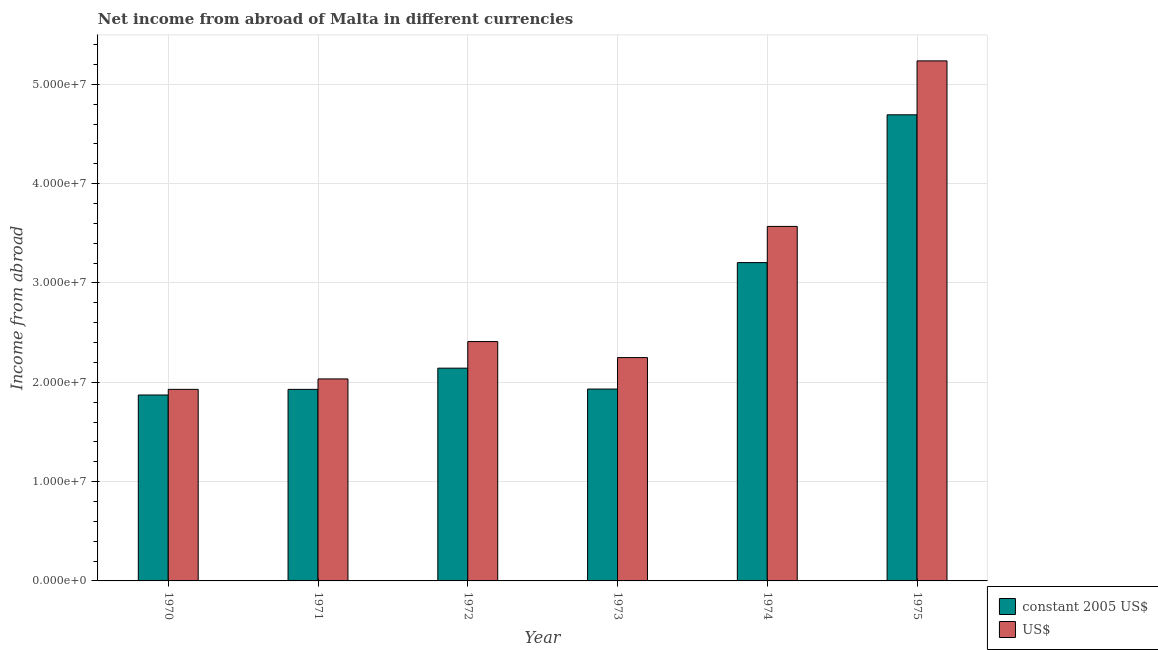How many different coloured bars are there?
Your answer should be compact. 2. Are the number of bars per tick equal to the number of legend labels?
Make the answer very short. Yes. What is the income from abroad in us$ in 1973?
Offer a terse response. 2.25e+07. Across all years, what is the maximum income from abroad in us$?
Your answer should be compact. 5.24e+07. Across all years, what is the minimum income from abroad in constant 2005 us$?
Your answer should be compact. 1.87e+07. In which year was the income from abroad in us$ maximum?
Your response must be concise. 1975. In which year was the income from abroad in us$ minimum?
Offer a terse response. 1970. What is the total income from abroad in us$ in the graph?
Keep it short and to the point. 1.74e+08. What is the difference between the income from abroad in constant 2005 us$ in 1970 and that in 1974?
Your answer should be very brief. -1.33e+07. What is the difference between the income from abroad in constant 2005 us$ in 1971 and the income from abroad in us$ in 1972?
Offer a very short reply. -2.13e+06. What is the average income from abroad in us$ per year?
Offer a very short reply. 2.90e+07. What is the ratio of the income from abroad in us$ in 1972 to that in 1975?
Ensure brevity in your answer.  0.46. What is the difference between the highest and the second highest income from abroad in us$?
Offer a terse response. 1.67e+07. What is the difference between the highest and the lowest income from abroad in us$?
Give a very brief answer. 3.31e+07. What does the 2nd bar from the left in 1973 represents?
Your answer should be compact. US$. What does the 2nd bar from the right in 1972 represents?
Offer a terse response. Constant 2005 us$. How many years are there in the graph?
Make the answer very short. 6. What is the difference between two consecutive major ticks on the Y-axis?
Your answer should be very brief. 1.00e+07. Are the values on the major ticks of Y-axis written in scientific E-notation?
Give a very brief answer. Yes. How many legend labels are there?
Provide a short and direct response. 2. What is the title of the graph?
Offer a very short reply. Net income from abroad of Malta in different currencies. Does "Imports" appear as one of the legend labels in the graph?
Offer a terse response. No. What is the label or title of the Y-axis?
Offer a terse response. Income from abroad. What is the Income from abroad in constant 2005 US$ in 1970?
Provide a short and direct response. 1.87e+07. What is the Income from abroad of US$ in 1970?
Your answer should be compact. 1.93e+07. What is the Income from abroad of constant 2005 US$ in 1971?
Keep it short and to the point. 1.93e+07. What is the Income from abroad in US$ in 1971?
Keep it short and to the point. 2.03e+07. What is the Income from abroad of constant 2005 US$ in 1972?
Provide a short and direct response. 2.14e+07. What is the Income from abroad of US$ in 1972?
Make the answer very short. 2.41e+07. What is the Income from abroad in constant 2005 US$ in 1973?
Your answer should be very brief. 1.93e+07. What is the Income from abroad in US$ in 1973?
Your answer should be very brief. 2.25e+07. What is the Income from abroad in constant 2005 US$ in 1974?
Your response must be concise. 3.21e+07. What is the Income from abroad in US$ in 1974?
Ensure brevity in your answer.  3.57e+07. What is the Income from abroad in constant 2005 US$ in 1975?
Make the answer very short. 4.69e+07. What is the Income from abroad in US$ in 1975?
Offer a very short reply. 5.24e+07. Across all years, what is the maximum Income from abroad in constant 2005 US$?
Ensure brevity in your answer.  4.69e+07. Across all years, what is the maximum Income from abroad of US$?
Your response must be concise. 5.24e+07. Across all years, what is the minimum Income from abroad in constant 2005 US$?
Your answer should be very brief. 1.87e+07. Across all years, what is the minimum Income from abroad of US$?
Offer a very short reply. 1.93e+07. What is the total Income from abroad in constant 2005 US$ in the graph?
Provide a short and direct response. 1.58e+08. What is the total Income from abroad of US$ in the graph?
Provide a succinct answer. 1.74e+08. What is the difference between the Income from abroad in constant 2005 US$ in 1970 and that in 1971?
Make the answer very short. -5.66e+05. What is the difference between the Income from abroad in US$ in 1970 and that in 1971?
Provide a short and direct response. -1.05e+06. What is the difference between the Income from abroad in constant 2005 US$ in 1970 and that in 1972?
Your response must be concise. -2.70e+06. What is the difference between the Income from abroad in US$ in 1970 and that in 1972?
Offer a terse response. -4.81e+06. What is the difference between the Income from abroad of constant 2005 US$ in 1970 and that in 1973?
Offer a very short reply. -5.97e+05. What is the difference between the Income from abroad of US$ in 1970 and that in 1973?
Offer a very short reply. -3.20e+06. What is the difference between the Income from abroad in constant 2005 US$ in 1970 and that in 1974?
Keep it short and to the point. -1.33e+07. What is the difference between the Income from abroad of US$ in 1970 and that in 1974?
Your answer should be compact. -1.64e+07. What is the difference between the Income from abroad of constant 2005 US$ in 1970 and that in 1975?
Keep it short and to the point. -2.82e+07. What is the difference between the Income from abroad of US$ in 1970 and that in 1975?
Your answer should be very brief. -3.31e+07. What is the difference between the Income from abroad of constant 2005 US$ in 1971 and that in 1972?
Your response must be concise. -2.13e+06. What is the difference between the Income from abroad of US$ in 1971 and that in 1972?
Offer a very short reply. -3.76e+06. What is the difference between the Income from abroad of constant 2005 US$ in 1971 and that in 1973?
Keep it short and to the point. -3.07e+04. What is the difference between the Income from abroad in US$ in 1971 and that in 1973?
Your answer should be compact. -2.15e+06. What is the difference between the Income from abroad of constant 2005 US$ in 1971 and that in 1974?
Provide a short and direct response. -1.28e+07. What is the difference between the Income from abroad in US$ in 1971 and that in 1974?
Your response must be concise. -1.54e+07. What is the difference between the Income from abroad in constant 2005 US$ in 1971 and that in 1975?
Provide a short and direct response. -2.76e+07. What is the difference between the Income from abroad of US$ in 1971 and that in 1975?
Your response must be concise. -3.20e+07. What is the difference between the Income from abroad in constant 2005 US$ in 1972 and that in 1973?
Your answer should be very brief. 2.10e+06. What is the difference between the Income from abroad in US$ in 1972 and that in 1973?
Make the answer very short. 1.61e+06. What is the difference between the Income from abroad of constant 2005 US$ in 1972 and that in 1974?
Your response must be concise. -1.06e+07. What is the difference between the Income from abroad of US$ in 1972 and that in 1974?
Your response must be concise. -1.16e+07. What is the difference between the Income from abroad in constant 2005 US$ in 1972 and that in 1975?
Provide a succinct answer. -2.55e+07. What is the difference between the Income from abroad of US$ in 1972 and that in 1975?
Provide a succinct answer. -2.83e+07. What is the difference between the Income from abroad of constant 2005 US$ in 1973 and that in 1974?
Ensure brevity in your answer.  -1.27e+07. What is the difference between the Income from abroad of US$ in 1973 and that in 1974?
Offer a very short reply. -1.32e+07. What is the difference between the Income from abroad of constant 2005 US$ in 1973 and that in 1975?
Your response must be concise. -2.76e+07. What is the difference between the Income from abroad in US$ in 1973 and that in 1975?
Offer a terse response. -2.99e+07. What is the difference between the Income from abroad in constant 2005 US$ in 1974 and that in 1975?
Make the answer very short. -1.49e+07. What is the difference between the Income from abroad of US$ in 1974 and that in 1975?
Make the answer very short. -1.67e+07. What is the difference between the Income from abroad of constant 2005 US$ in 1970 and the Income from abroad of US$ in 1971?
Offer a very short reply. -1.62e+06. What is the difference between the Income from abroad in constant 2005 US$ in 1970 and the Income from abroad in US$ in 1972?
Make the answer very short. -5.38e+06. What is the difference between the Income from abroad of constant 2005 US$ in 1970 and the Income from abroad of US$ in 1973?
Provide a short and direct response. -3.77e+06. What is the difference between the Income from abroad of constant 2005 US$ in 1970 and the Income from abroad of US$ in 1974?
Your answer should be compact. -1.70e+07. What is the difference between the Income from abroad in constant 2005 US$ in 1970 and the Income from abroad in US$ in 1975?
Provide a short and direct response. -3.36e+07. What is the difference between the Income from abroad of constant 2005 US$ in 1971 and the Income from abroad of US$ in 1972?
Your response must be concise. -4.81e+06. What is the difference between the Income from abroad of constant 2005 US$ in 1971 and the Income from abroad of US$ in 1973?
Give a very brief answer. -3.20e+06. What is the difference between the Income from abroad in constant 2005 US$ in 1971 and the Income from abroad in US$ in 1974?
Your answer should be compact. -1.64e+07. What is the difference between the Income from abroad of constant 2005 US$ in 1971 and the Income from abroad of US$ in 1975?
Keep it short and to the point. -3.31e+07. What is the difference between the Income from abroad of constant 2005 US$ in 1972 and the Income from abroad of US$ in 1973?
Provide a short and direct response. -1.07e+06. What is the difference between the Income from abroad in constant 2005 US$ in 1972 and the Income from abroad in US$ in 1974?
Your answer should be compact. -1.43e+07. What is the difference between the Income from abroad in constant 2005 US$ in 1972 and the Income from abroad in US$ in 1975?
Ensure brevity in your answer.  -3.09e+07. What is the difference between the Income from abroad in constant 2005 US$ in 1973 and the Income from abroad in US$ in 1974?
Your answer should be very brief. -1.64e+07. What is the difference between the Income from abroad of constant 2005 US$ in 1973 and the Income from abroad of US$ in 1975?
Keep it short and to the point. -3.30e+07. What is the difference between the Income from abroad of constant 2005 US$ in 1974 and the Income from abroad of US$ in 1975?
Provide a short and direct response. -2.03e+07. What is the average Income from abroad of constant 2005 US$ per year?
Ensure brevity in your answer.  2.63e+07. What is the average Income from abroad in US$ per year?
Provide a short and direct response. 2.90e+07. In the year 1970, what is the difference between the Income from abroad of constant 2005 US$ and Income from abroad of US$?
Offer a very short reply. -5.68e+05. In the year 1971, what is the difference between the Income from abroad in constant 2005 US$ and Income from abroad in US$?
Your answer should be very brief. -1.05e+06. In the year 1972, what is the difference between the Income from abroad in constant 2005 US$ and Income from abroad in US$?
Offer a very short reply. -2.68e+06. In the year 1973, what is the difference between the Income from abroad in constant 2005 US$ and Income from abroad in US$?
Ensure brevity in your answer.  -3.17e+06. In the year 1974, what is the difference between the Income from abroad of constant 2005 US$ and Income from abroad of US$?
Ensure brevity in your answer.  -3.64e+06. In the year 1975, what is the difference between the Income from abroad in constant 2005 US$ and Income from abroad in US$?
Make the answer very short. -5.43e+06. What is the ratio of the Income from abroad of constant 2005 US$ in 1970 to that in 1971?
Provide a succinct answer. 0.97. What is the ratio of the Income from abroad in US$ in 1970 to that in 1971?
Make the answer very short. 0.95. What is the ratio of the Income from abroad of constant 2005 US$ in 1970 to that in 1972?
Your answer should be compact. 0.87. What is the ratio of the Income from abroad of US$ in 1970 to that in 1972?
Provide a short and direct response. 0.8. What is the ratio of the Income from abroad of constant 2005 US$ in 1970 to that in 1973?
Your response must be concise. 0.97. What is the ratio of the Income from abroad in US$ in 1970 to that in 1973?
Make the answer very short. 0.86. What is the ratio of the Income from abroad in constant 2005 US$ in 1970 to that in 1974?
Provide a succinct answer. 0.58. What is the ratio of the Income from abroad in US$ in 1970 to that in 1974?
Offer a very short reply. 0.54. What is the ratio of the Income from abroad of constant 2005 US$ in 1970 to that in 1975?
Keep it short and to the point. 0.4. What is the ratio of the Income from abroad of US$ in 1970 to that in 1975?
Your answer should be compact. 0.37. What is the ratio of the Income from abroad of constant 2005 US$ in 1971 to that in 1972?
Your answer should be very brief. 0.9. What is the ratio of the Income from abroad of US$ in 1971 to that in 1972?
Offer a very short reply. 0.84. What is the ratio of the Income from abroad in constant 2005 US$ in 1971 to that in 1973?
Your response must be concise. 1. What is the ratio of the Income from abroad in US$ in 1971 to that in 1973?
Make the answer very short. 0.9. What is the ratio of the Income from abroad in constant 2005 US$ in 1971 to that in 1974?
Provide a short and direct response. 0.6. What is the ratio of the Income from abroad of US$ in 1971 to that in 1974?
Your response must be concise. 0.57. What is the ratio of the Income from abroad in constant 2005 US$ in 1971 to that in 1975?
Provide a succinct answer. 0.41. What is the ratio of the Income from abroad of US$ in 1971 to that in 1975?
Your answer should be compact. 0.39. What is the ratio of the Income from abroad in constant 2005 US$ in 1972 to that in 1973?
Make the answer very short. 1.11. What is the ratio of the Income from abroad in US$ in 1972 to that in 1973?
Your answer should be very brief. 1.07. What is the ratio of the Income from abroad of constant 2005 US$ in 1972 to that in 1974?
Your response must be concise. 0.67. What is the ratio of the Income from abroad of US$ in 1972 to that in 1974?
Your answer should be very brief. 0.68. What is the ratio of the Income from abroad of constant 2005 US$ in 1972 to that in 1975?
Keep it short and to the point. 0.46. What is the ratio of the Income from abroad in US$ in 1972 to that in 1975?
Provide a short and direct response. 0.46. What is the ratio of the Income from abroad of constant 2005 US$ in 1973 to that in 1974?
Provide a short and direct response. 0.6. What is the ratio of the Income from abroad in US$ in 1973 to that in 1974?
Offer a terse response. 0.63. What is the ratio of the Income from abroad of constant 2005 US$ in 1973 to that in 1975?
Ensure brevity in your answer.  0.41. What is the ratio of the Income from abroad in US$ in 1973 to that in 1975?
Make the answer very short. 0.43. What is the ratio of the Income from abroad of constant 2005 US$ in 1974 to that in 1975?
Your answer should be very brief. 0.68. What is the ratio of the Income from abroad in US$ in 1974 to that in 1975?
Give a very brief answer. 0.68. What is the difference between the highest and the second highest Income from abroad in constant 2005 US$?
Offer a terse response. 1.49e+07. What is the difference between the highest and the second highest Income from abroad in US$?
Provide a short and direct response. 1.67e+07. What is the difference between the highest and the lowest Income from abroad in constant 2005 US$?
Your response must be concise. 2.82e+07. What is the difference between the highest and the lowest Income from abroad of US$?
Offer a terse response. 3.31e+07. 